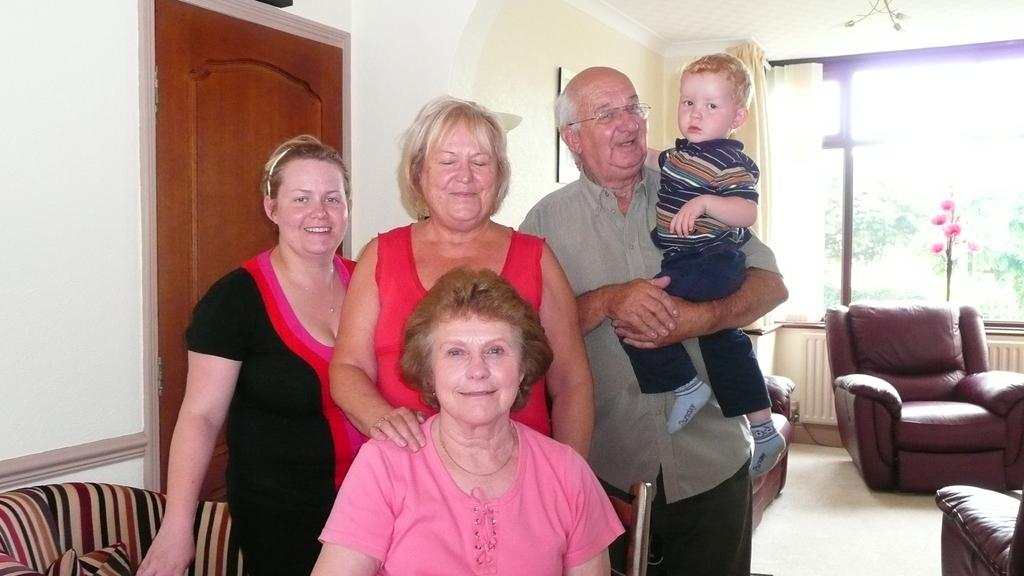How many people are present in the image? There are persons in the image, but the exact number cannot be determined from the provided facts. What type of surface is visible in the image? There is a floor in the image. What type of furniture is present in the image? There are sofas in the image. What architectural feature is present in the image? There is a door in the image. What type of wall is visible in the image? There is a wall in the image. What type of opening is present in the wall? There is a window in the image. What type of window treatment is associated with the window? There is a curtain associated with the window. What type of instrument is being played by the persons in the image? There is no information about any instruments being played in the image. What type of ground is visible in the image? The provided facts do not mention any ground in the image. 